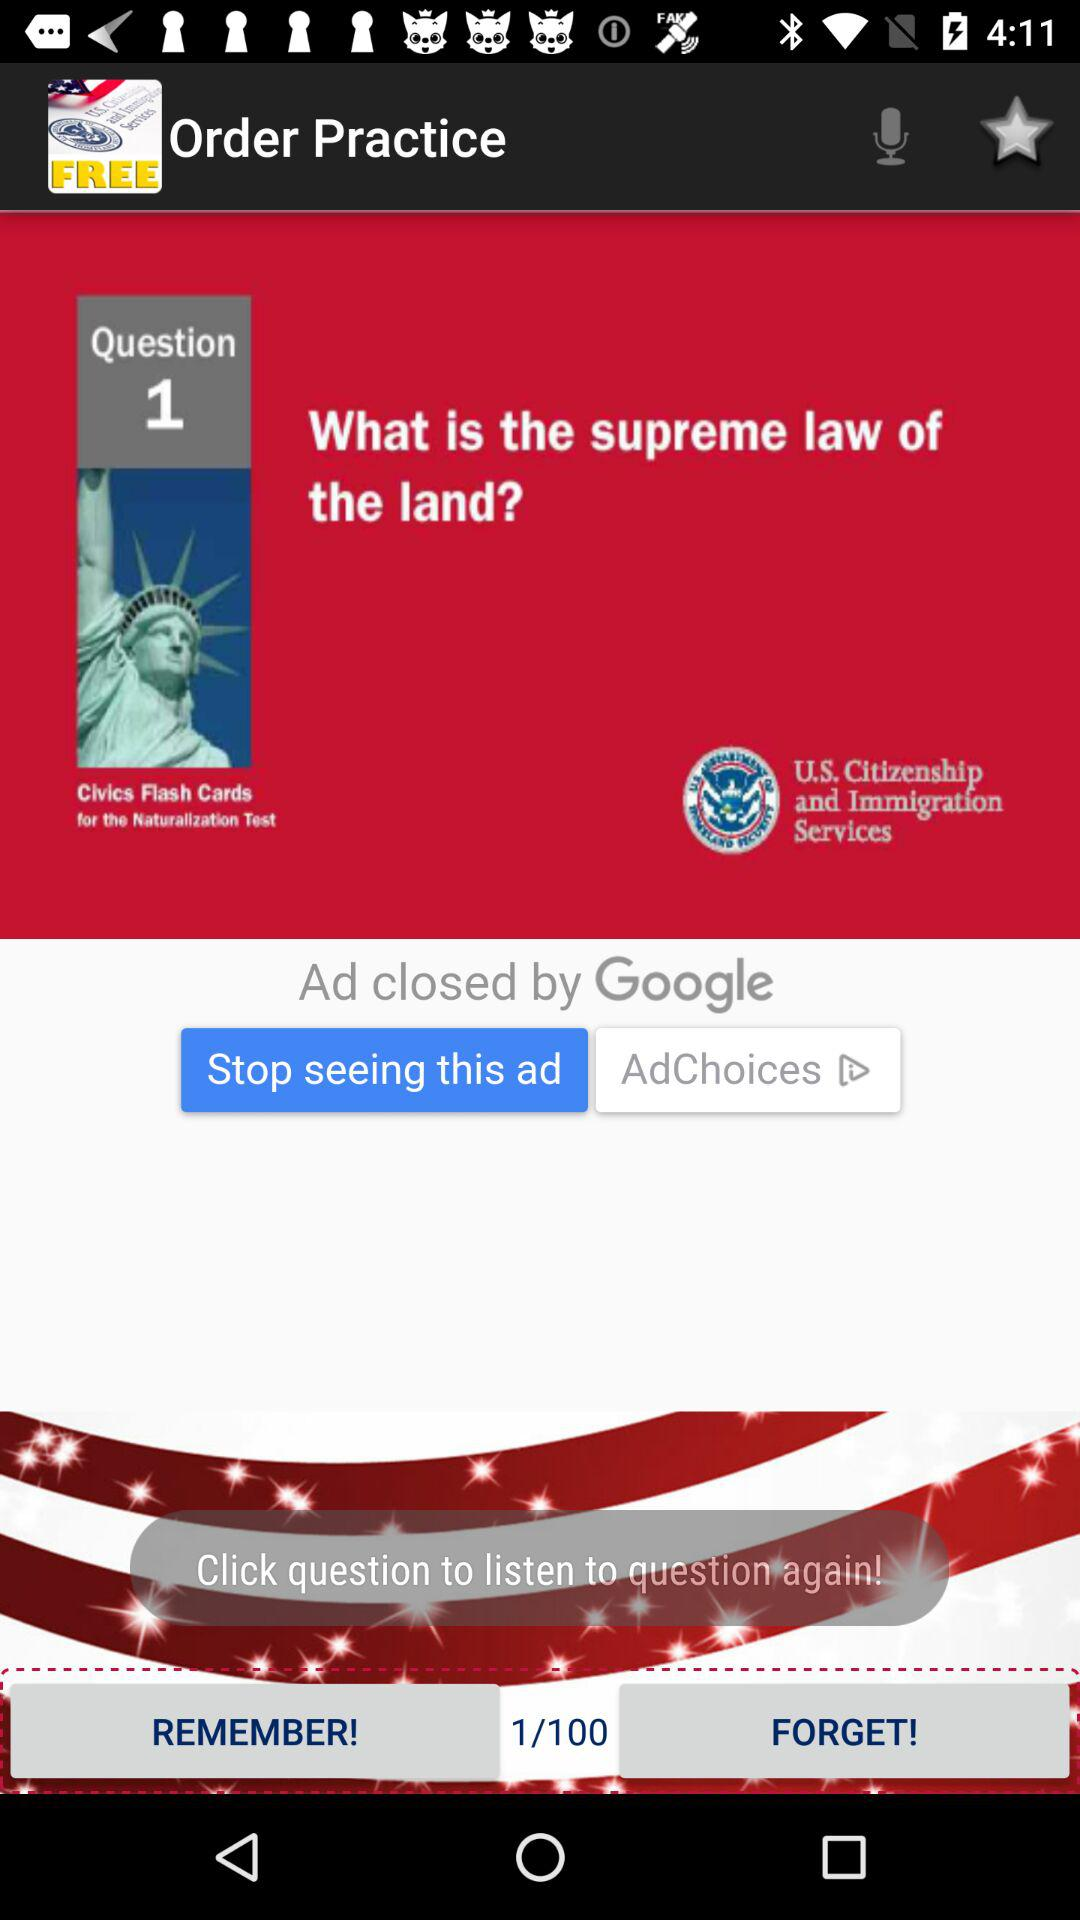How many questions in total are there? There are 100 questions in total. 